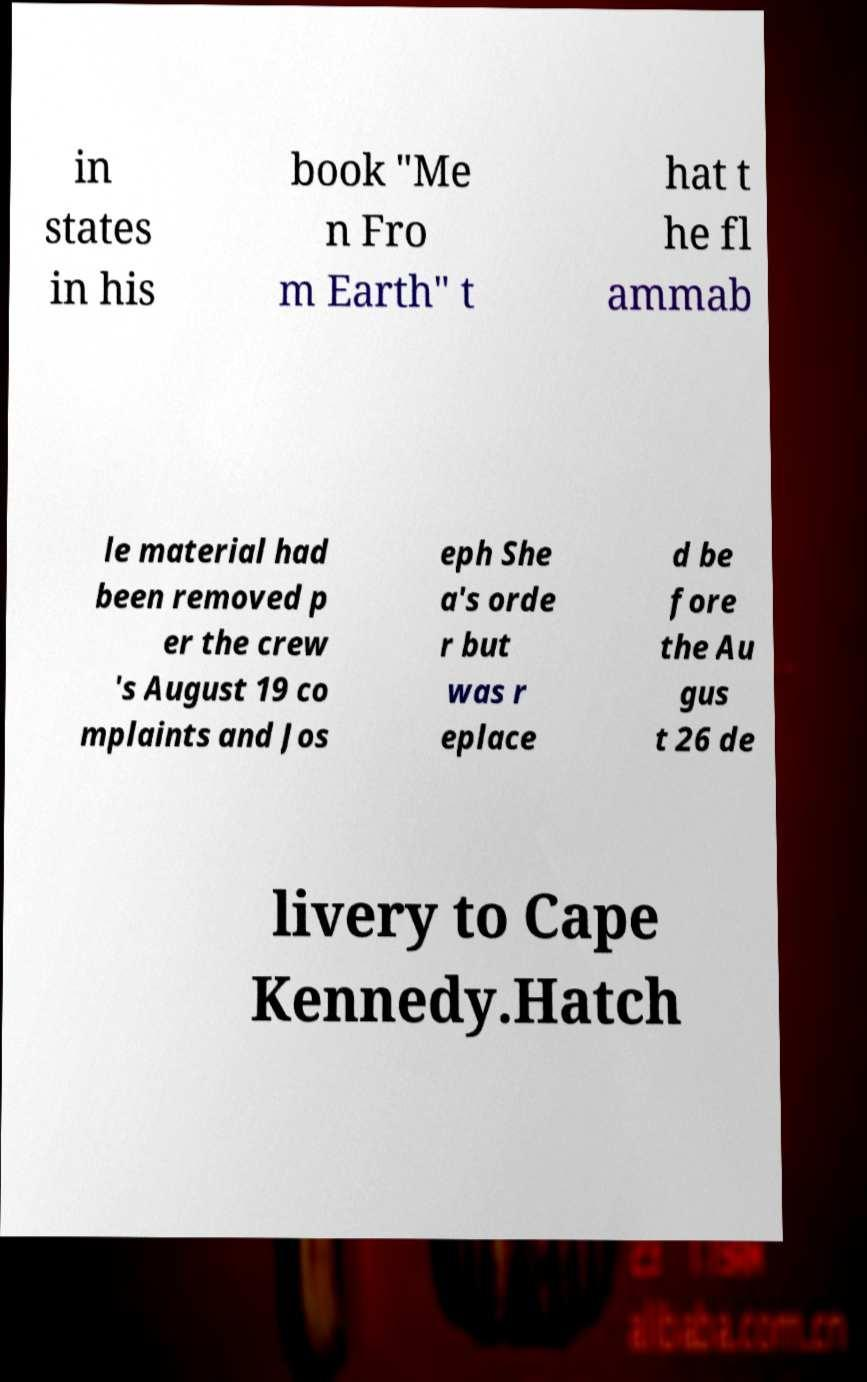Could you extract and type out the text from this image? in states in his book "Me n Fro m Earth" t hat t he fl ammab le material had been removed p er the crew 's August 19 co mplaints and Jos eph She a's orde r but was r eplace d be fore the Au gus t 26 de livery to Cape Kennedy.Hatch 